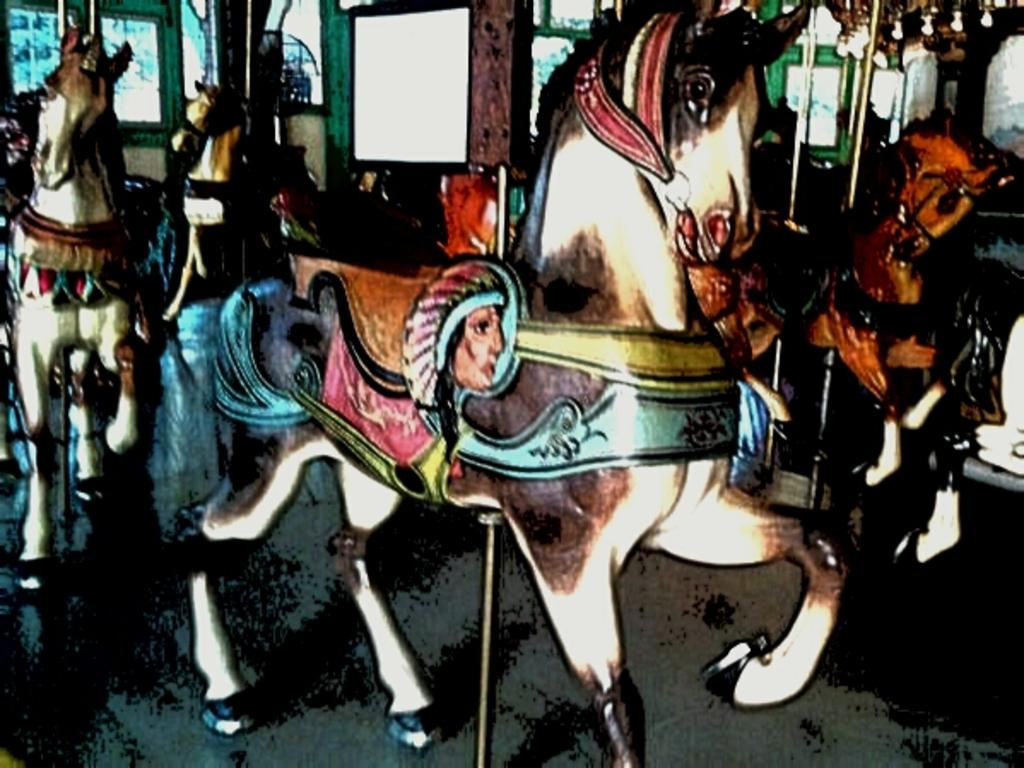What is depicted in the painting in the image? There is a painting of horses in the image. How many plates are stacked on top of the horse's ear in the image? There are no plates or ears present in the image, as it features a painting of horses. 